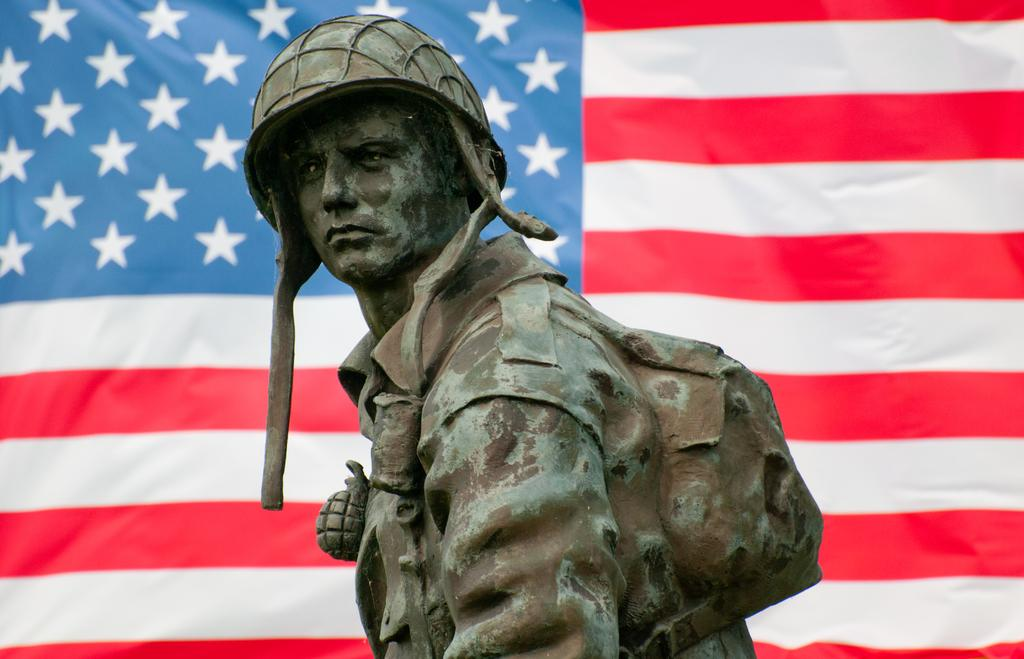What is the main subject in the image? There is a statue of a person in the image. What can be seen in the background of the image? There is a flag in the background of the image. How many boys are playing chess in the image? There are no boys or chess games present in the image. What type of haircut does the statue have? The statue does not have a haircut, as it is a sculpture and not a living person. 